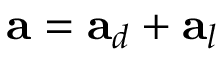Convert formula to latex. <formula><loc_0><loc_0><loc_500><loc_500>a = a _ { d } + a _ { l }</formula> 